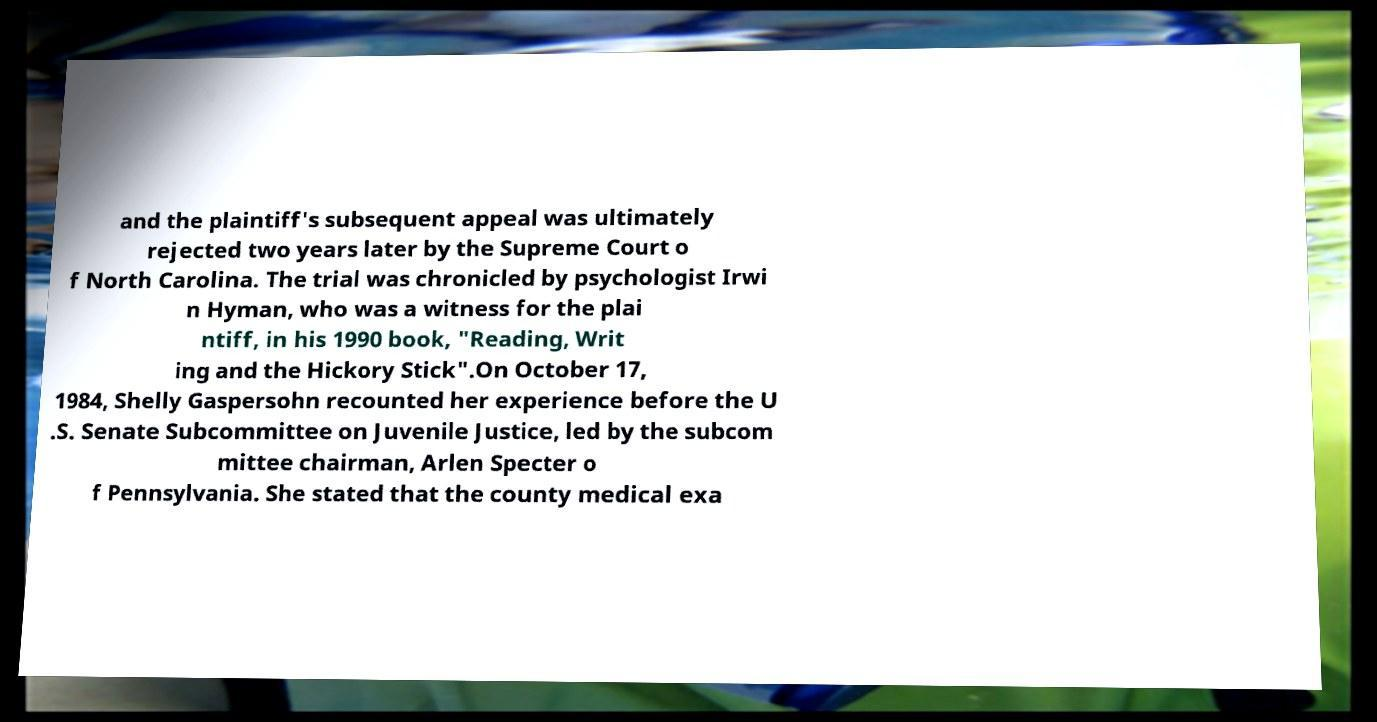There's text embedded in this image that I need extracted. Can you transcribe it verbatim? and the plaintiff's subsequent appeal was ultimately rejected two years later by the Supreme Court o f North Carolina. The trial was chronicled by psychologist Irwi n Hyman, who was a witness for the plai ntiff, in his 1990 book, "Reading, Writ ing and the Hickory Stick".On October 17, 1984, Shelly Gaspersohn recounted her experience before the U .S. Senate Subcommittee on Juvenile Justice, led by the subcom mittee chairman, Arlen Specter o f Pennsylvania. She stated that the county medical exa 